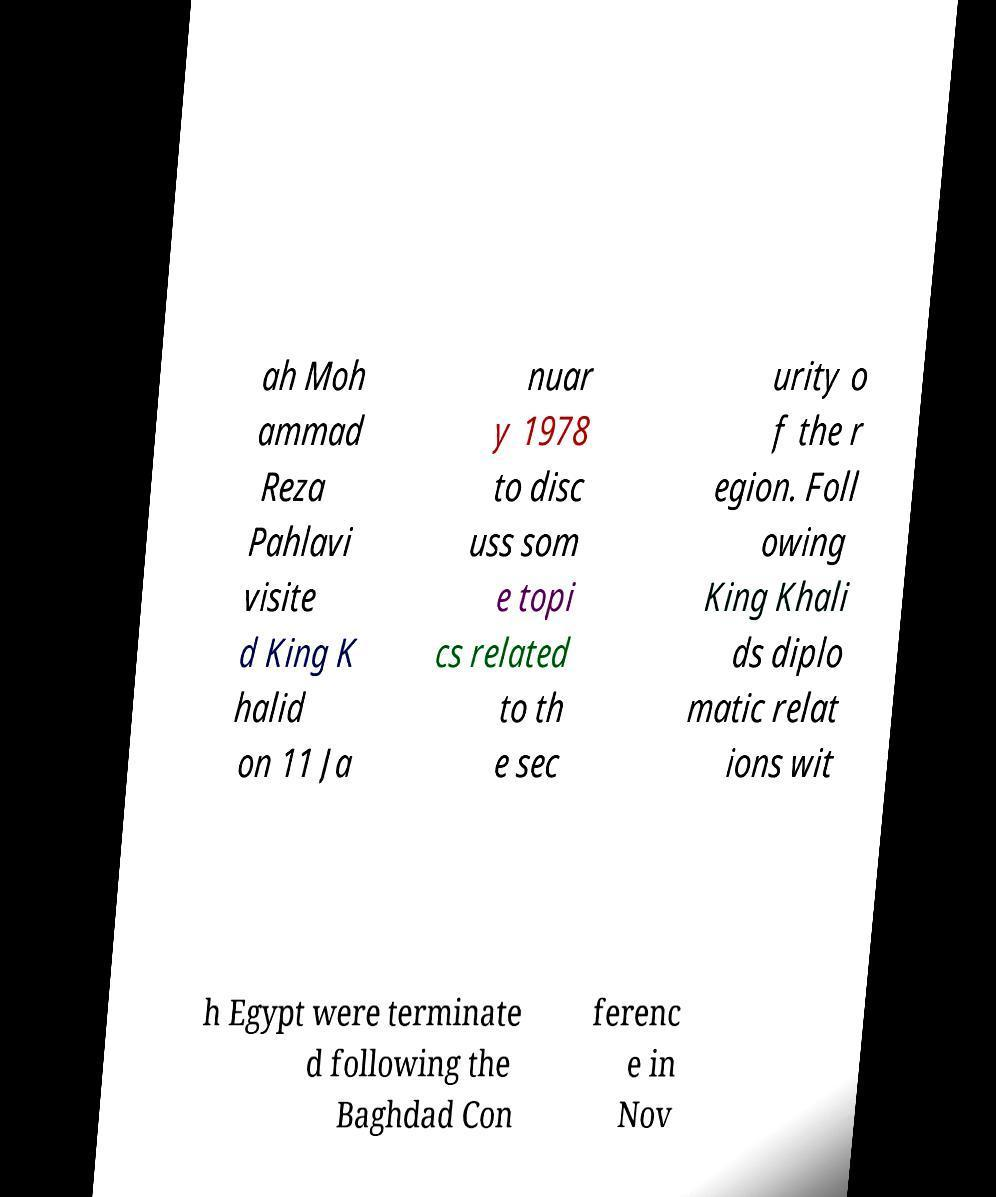Can you read and provide the text displayed in the image?This photo seems to have some interesting text. Can you extract and type it out for me? ah Moh ammad Reza Pahlavi visite d King K halid on 11 Ja nuar y 1978 to disc uss som e topi cs related to th e sec urity o f the r egion. Foll owing King Khali ds diplo matic relat ions wit h Egypt were terminate d following the Baghdad Con ferenc e in Nov 